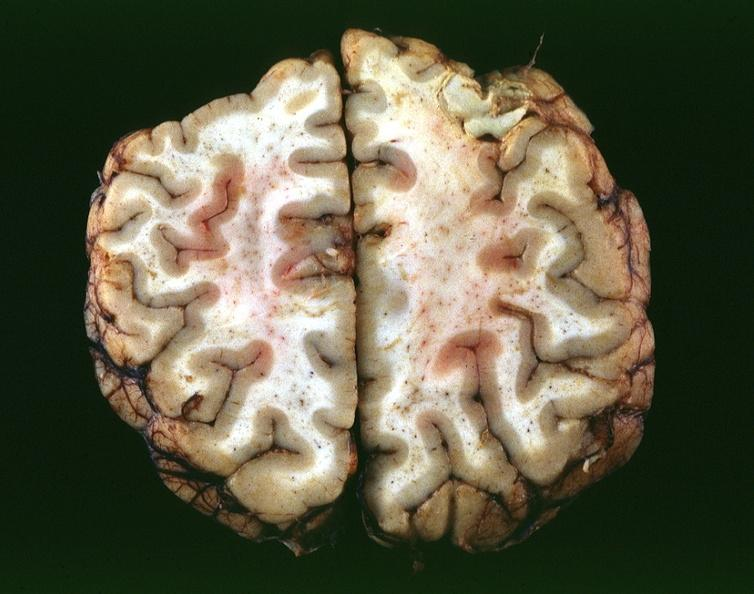what is present?
Answer the question using a single word or phrase. Nervous 